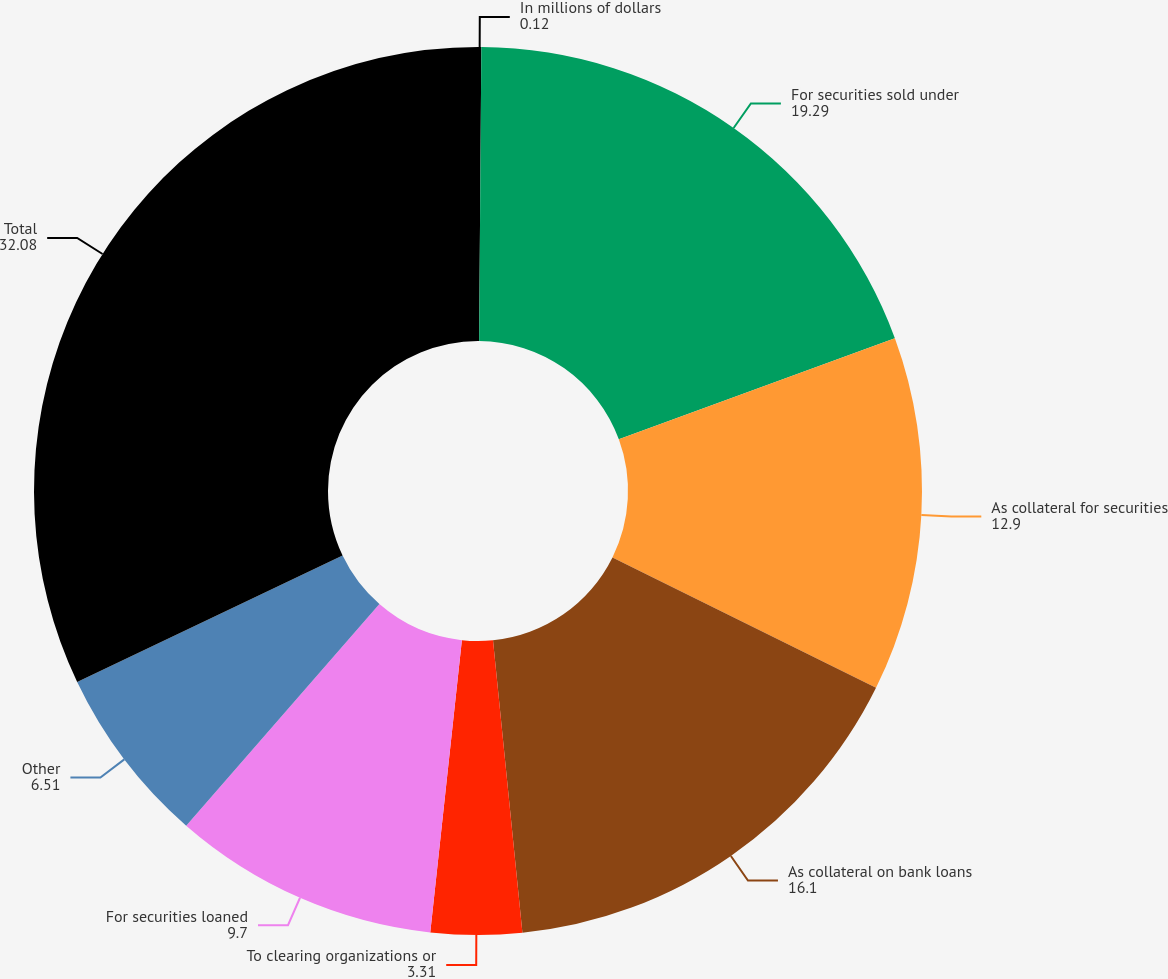Convert chart. <chart><loc_0><loc_0><loc_500><loc_500><pie_chart><fcel>In millions of dollars<fcel>For securities sold under<fcel>As collateral for securities<fcel>As collateral on bank loans<fcel>To clearing organizations or<fcel>For securities loaned<fcel>Other<fcel>Total<nl><fcel>0.12%<fcel>19.29%<fcel>12.9%<fcel>16.1%<fcel>3.31%<fcel>9.7%<fcel>6.51%<fcel>32.08%<nl></chart> 